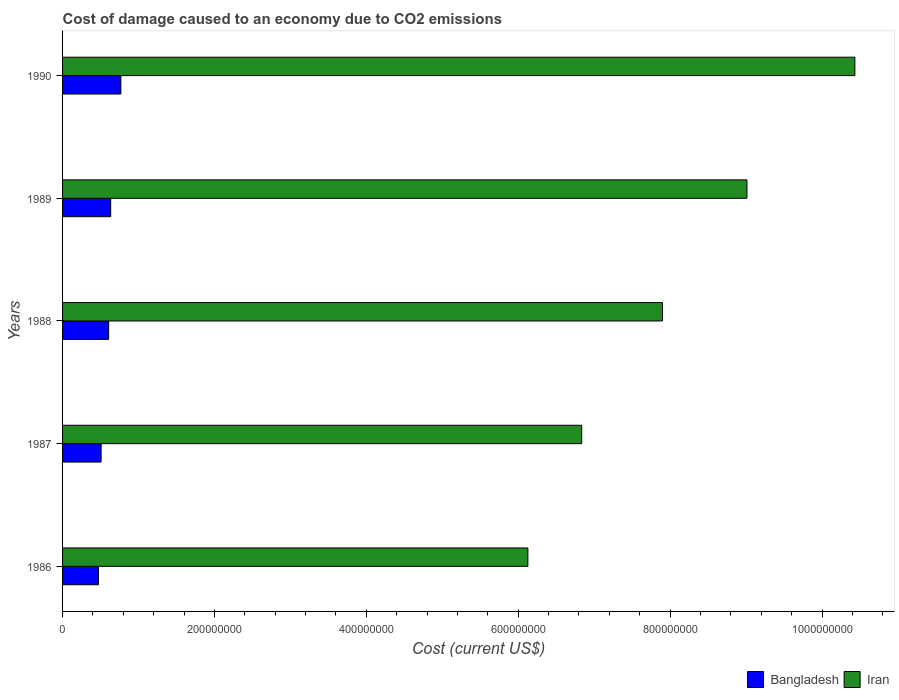How many groups of bars are there?
Offer a very short reply. 5. Are the number of bars on each tick of the Y-axis equal?
Ensure brevity in your answer.  Yes. How many bars are there on the 5th tick from the top?
Make the answer very short. 2. In how many cases, is the number of bars for a given year not equal to the number of legend labels?
Give a very brief answer. 0. What is the cost of damage caused due to CO2 emissisons in Iran in 1988?
Your answer should be very brief. 7.90e+08. Across all years, what is the maximum cost of damage caused due to CO2 emissisons in Bangladesh?
Provide a short and direct response. 7.68e+07. Across all years, what is the minimum cost of damage caused due to CO2 emissisons in Iran?
Ensure brevity in your answer.  6.13e+08. In which year was the cost of damage caused due to CO2 emissisons in Bangladesh maximum?
Your answer should be compact. 1990. In which year was the cost of damage caused due to CO2 emissisons in Iran minimum?
Keep it short and to the point. 1986. What is the total cost of damage caused due to CO2 emissisons in Iran in the graph?
Your answer should be compact. 4.03e+09. What is the difference between the cost of damage caused due to CO2 emissisons in Bangladesh in 1986 and that in 1989?
Ensure brevity in your answer.  -1.61e+07. What is the difference between the cost of damage caused due to CO2 emissisons in Bangladesh in 1987 and the cost of damage caused due to CO2 emissisons in Iran in 1988?
Your answer should be compact. -7.39e+08. What is the average cost of damage caused due to CO2 emissisons in Iran per year?
Keep it short and to the point. 8.06e+08. In the year 1986, what is the difference between the cost of damage caused due to CO2 emissisons in Iran and cost of damage caused due to CO2 emissisons in Bangladesh?
Give a very brief answer. 5.65e+08. What is the ratio of the cost of damage caused due to CO2 emissisons in Bangladesh in 1988 to that in 1989?
Your response must be concise. 0.96. What is the difference between the highest and the second highest cost of damage caused due to CO2 emissisons in Bangladesh?
Provide a succinct answer. 1.34e+07. What is the difference between the highest and the lowest cost of damage caused due to CO2 emissisons in Bangladesh?
Keep it short and to the point. 2.95e+07. In how many years, is the cost of damage caused due to CO2 emissisons in Bangladesh greater than the average cost of damage caused due to CO2 emissisons in Bangladesh taken over all years?
Offer a very short reply. 3. Is the sum of the cost of damage caused due to CO2 emissisons in Bangladesh in 1988 and 1990 greater than the maximum cost of damage caused due to CO2 emissisons in Iran across all years?
Give a very brief answer. No. What does the 1st bar from the top in 1987 represents?
Your response must be concise. Iran. What does the 1st bar from the bottom in 1990 represents?
Ensure brevity in your answer.  Bangladesh. What is the difference between two consecutive major ticks on the X-axis?
Your answer should be compact. 2.00e+08. Does the graph contain grids?
Offer a terse response. No. Where does the legend appear in the graph?
Make the answer very short. Bottom right. How many legend labels are there?
Give a very brief answer. 2. How are the legend labels stacked?
Provide a succinct answer. Horizontal. What is the title of the graph?
Keep it short and to the point. Cost of damage caused to an economy due to CO2 emissions. What is the label or title of the X-axis?
Keep it short and to the point. Cost (current US$). What is the label or title of the Y-axis?
Give a very brief answer. Years. What is the Cost (current US$) of Bangladesh in 1986?
Give a very brief answer. 4.73e+07. What is the Cost (current US$) of Iran in 1986?
Ensure brevity in your answer.  6.13e+08. What is the Cost (current US$) of Bangladesh in 1987?
Offer a very short reply. 5.08e+07. What is the Cost (current US$) in Iran in 1987?
Your answer should be compact. 6.84e+08. What is the Cost (current US$) in Bangladesh in 1988?
Provide a short and direct response. 6.07e+07. What is the Cost (current US$) of Iran in 1988?
Offer a terse response. 7.90e+08. What is the Cost (current US$) in Bangladesh in 1989?
Ensure brevity in your answer.  6.34e+07. What is the Cost (current US$) in Iran in 1989?
Offer a very short reply. 9.01e+08. What is the Cost (current US$) in Bangladesh in 1990?
Your response must be concise. 7.68e+07. What is the Cost (current US$) of Iran in 1990?
Give a very brief answer. 1.04e+09. Across all years, what is the maximum Cost (current US$) of Bangladesh?
Provide a succinct answer. 7.68e+07. Across all years, what is the maximum Cost (current US$) of Iran?
Provide a short and direct response. 1.04e+09. Across all years, what is the minimum Cost (current US$) in Bangladesh?
Ensure brevity in your answer.  4.73e+07. Across all years, what is the minimum Cost (current US$) of Iran?
Your answer should be very brief. 6.13e+08. What is the total Cost (current US$) in Bangladesh in the graph?
Provide a short and direct response. 2.99e+08. What is the total Cost (current US$) in Iran in the graph?
Keep it short and to the point. 4.03e+09. What is the difference between the Cost (current US$) in Bangladesh in 1986 and that in 1987?
Keep it short and to the point. -3.49e+06. What is the difference between the Cost (current US$) in Iran in 1986 and that in 1987?
Make the answer very short. -7.08e+07. What is the difference between the Cost (current US$) in Bangladesh in 1986 and that in 1988?
Make the answer very short. -1.34e+07. What is the difference between the Cost (current US$) of Iran in 1986 and that in 1988?
Offer a terse response. -1.77e+08. What is the difference between the Cost (current US$) of Bangladesh in 1986 and that in 1989?
Your answer should be very brief. -1.61e+07. What is the difference between the Cost (current US$) in Iran in 1986 and that in 1989?
Your answer should be very brief. -2.88e+08. What is the difference between the Cost (current US$) of Bangladesh in 1986 and that in 1990?
Your answer should be compact. -2.95e+07. What is the difference between the Cost (current US$) of Iran in 1986 and that in 1990?
Provide a short and direct response. -4.31e+08. What is the difference between the Cost (current US$) of Bangladesh in 1987 and that in 1988?
Provide a short and direct response. -9.94e+06. What is the difference between the Cost (current US$) of Iran in 1987 and that in 1988?
Provide a short and direct response. -1.06e+08. What is the difference between the Cost (current US$) in Bangladesh in 1987 and that in 1989?
Your response must be concise. -1.26e+07. What is the difference between the Cost (current US$) of Iran in 1987 and that in 1989?
Your answer should be very brief. -2.18e+08. What is the difference between the Cost (current US$) of Bangladesh in 1987 and that in 1990?
Give a very brief answer. -2.60e+07. What is the difference between the Cost (current US$) in Iran in 1987 and that in 1990?
Make the answer very short. -3.60e+08. What is the difference between the Cost (current US$) in Bangladesh in 1988 and that in 1989?
Give a very brief answer. -2.67e+06. What is the difference between the Cost (current US$) of Iran in 1988 and that in 1989?
Provide a short and direct response. -1.11e+08. What is the difference between the Cost (current US$) of Bangladesh in 1988 and that in 1990?
Keep it short and to the point. -1.61e+07. What is the difference between the Cost (current US$) of Iran in 1988 and that in 1990?
Your answer should be very brief. -2.53e+08. What is the difference between the Cost (current US$) of Bangladesh in 1989 and that in 1990?
Make the answer very short. -1.34e+07. What is the difference between the Cost (current US$) of Iran in 1989 and that in 1990?
Provide a short and direct response. -1.42e+08. What is the difference between the Cost (current US$) of Bangladesh in 1986 and the Cost (current US$) of Iran in 1987?
Ensure brevity in your answer.  -6.36e+08. What is the difference between the Cost (current US$) in Bangladesh in 1986 and the Cost (current US$) in Iran in 1988?
Ensure brevity in your answer.  -7.43e+08. What is the difference between the Cost (current US$) of Bangladesh in 1986 and the Cost (current US$) of Iran in 1989?
Offer a terse response. -8.54e+08. What is the difference between the Cost (current US$) in Bangladesh in 1986 and the Cost (current US$) in Iran in 1990?
Your answer should be very brief. -9.96e+08. What is the difference between the Cost (current US$) in Bangladesh in 1987 and the Cost (current US$) in Iran in 1988?
Provide a succinct answer. -7.39e+08. What is the difference between the Cost (current US$) of Bangladesh in 1987 and the Cost (current US$) of Iran in 1989?
Your answer should be compact. -8.50e+08. What is the difference between the Cost (current US$) of Bangladesh in 1987 and the Cost (current US$) of Iran in 1990?
Provide a short and direct response. -9.93e+08. What is the difference between the Cost (current US$) of Bangladesh in 1988 and the Cost (current US$) of Iran in 1989?
Provide a succinct answer. -8.40e+08. What is the difference between the Cost (current US$) in Bangladesh in 1988 and the Cost (current US$) in Iran in 1990?
Keep it short and to the point. -9.83e+08. What is the difference between the Cost (current US$) in Bangladesh in 1989 and the Cost (current US$) in Iran in 1990?
Your response must be concise. -9.80e+08. What is the average Cost (current US$) in Bangladesh per year?
Ensure brevity in your answer.  5.98e+07. What is the average Cost (current US$) of Iran per year?
Keep it short and to the point. 8.06e+08. In the year 1986, what is the difference between the Cost (current US$) in Bangladesh and Cost (current US$) in Iran?
Your answer should be very brief. -5.65e+08. In the year 1987, what is the difference between the Cost (current US$) of Bangladesh and Cost (current US$) of Iran?
Provide a succinct answer. -6.33e+08. In the year 1988, what is the difference between the Cost (current US$) of Bangladesh and Cost (current US$) of Iran?
Offer a very short reply. -7.29e+08. In the year 1989, what is the difference between the Cost (current US$) in Bangladesh and Cost (current US$) in Iran?
Offer a terse response. -8.38e+08. In the year 1990, what is the difference between the Cost (current US$) of Bangladesh and Cost (current US$) of Iran?
Ensure brevity in your answer.  -9.67e+08. What is the ratio of the Cost (current US$) in Bangladesh in 1986 to that in 1987?
Offer a terse response. 0.93. What is the ratio of the Cost (current US$) of Iran in 1986 to that in 1987?
Give a very brief answer. 0.9. What is the ratio of the Cost (current US$) in Bangladesh in 1986 to that in 1988?
Your response must be concise. 0.78. What is the ratio of the Cost (current US$) of Iran in 1986 to that in 1988?
Give a very brief answer. 0.78. What is the ratio of the Cost (current US$) of Bangladesh in 1986 to that in 1989?
Offer a terse response. 0.75. What is the ratio of the Cost (current US$) in Iran in 1986 to that in 1989?
Your answer should be very brief. 0.68. What is the ratio of the Cost (current US$) of Bangladesh in 1986 to that in 1990?
Provide a succinct answer. 0.62. What is the ratio of the Cost (current US$) of Iran in 1986 to that in 1990?
Offer a very short reply. 0.59. What is the ratio of the Cost (current US$) of Bangladesh in 1987 to that in 1988?
Your response must be concise. 0.84. What is the ratio of the Cost (current US$) of Iran in 1987 to that in 1988?
Provide a short and direct response. 0.87. What is the ratio of the Cost (current US$) of Bangladesh in 1987 to that in 1989?
Ensure brevity in your answer.  0.8. What is the ratio of the Cost (current US$) in Iran in 1987 to that in 1989?
Offer a very short reply. 0.76. What is the ratio of the Cost (current US$) of Bangladesh in 1987 to that in 1990?
Make the answer very short. 0.66. What is the ratio of the Cost (current US$) in Iran in 1987 to that in 1990?
Provide a succinct answer. 0.66. What is the ratio of the Cost (current US$) of Bangladesh in 1988 to that in 1989?
Offer a very short reply. 0.96. What is the ratio of the Cost (current US$) of Iran in 1988 to that in 1989?
Your response must be concise. 0.88. What is the ratio of the Cost (current US$) in Bangladesh in 1988 to that in 1990?
Your answer should be very brief. 0.79. What is the ratio of the Cost (current US$) in Iran in 1988 to that in 1990?
Make the answer very short. 0.76. What is the ratio of the Cost (current US$) in Bangladesh in 1989 to that in 1990?
Your answer should be compact. 0.83. What is the ratio of the Cost (current US$) of Iran in 1989 to that in 1990?
Provide a short and direct response. 0.86. What is the difference between the highest and the second highest Cost (current US$) in Bangladesh?
Ensure brevity in your answer.  1.34e+07. What is the difference between the highest and the second highest Cost (current US$) of Iran?
Ensure brevity in your answer.  1.42e+08. What is the difference between the highest and the lowest Cost (current US$) of Bangladesh?
Give a very brief answer. 2.95e+07. What is the difference between the highest and the lowest Cost (current US$) in Iran?
Give a very brief answer. 4.31e+08. 